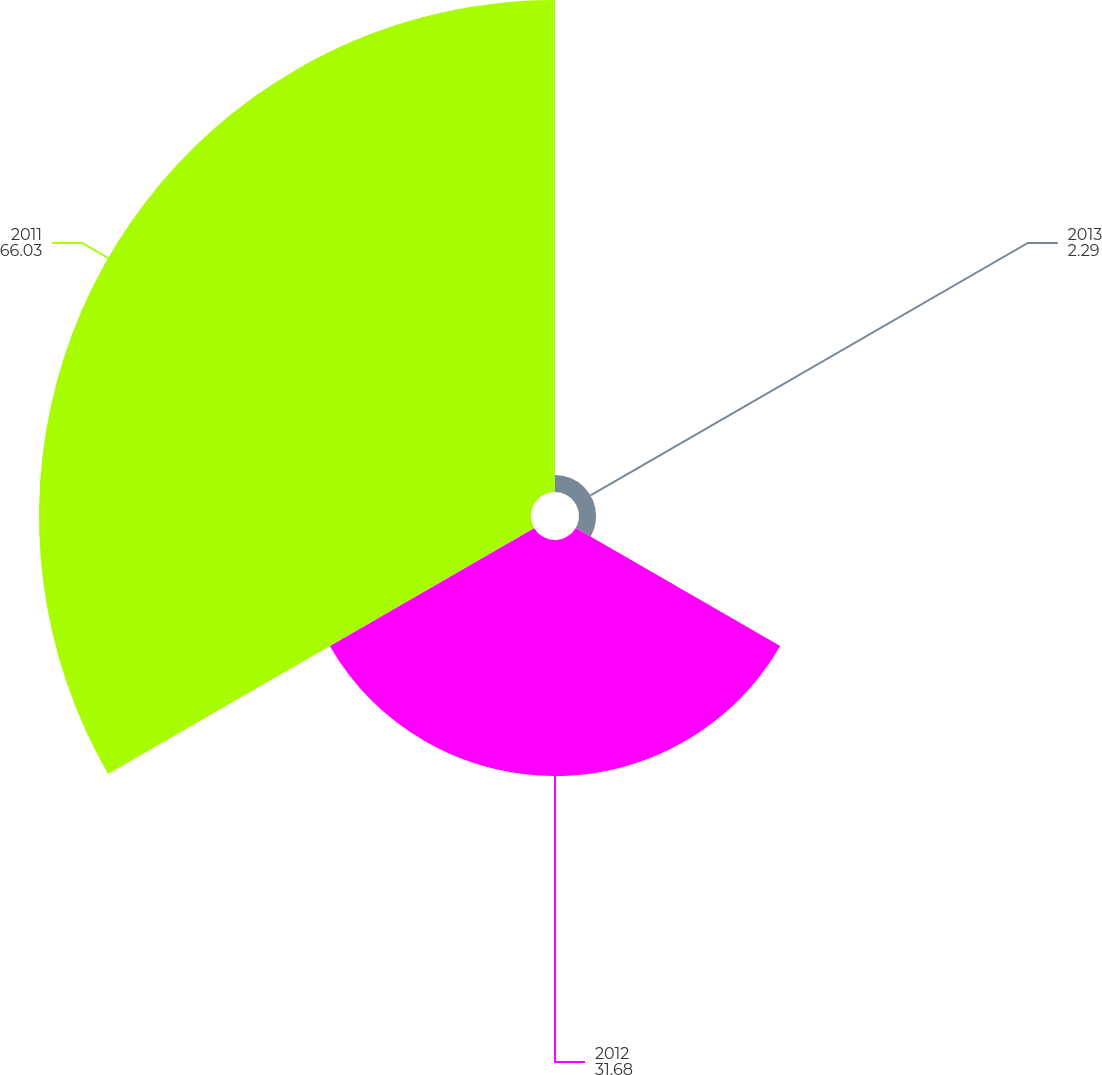Convert chart to OTSL. <chart><loc_0><loc_0><loc_500><loc_500><pie_chart><fcel>2013<fcel>2012<fcel>2011<nl><fcel>2.29%<fcel>31.68%<fcel>66.03%<nl></chart> 